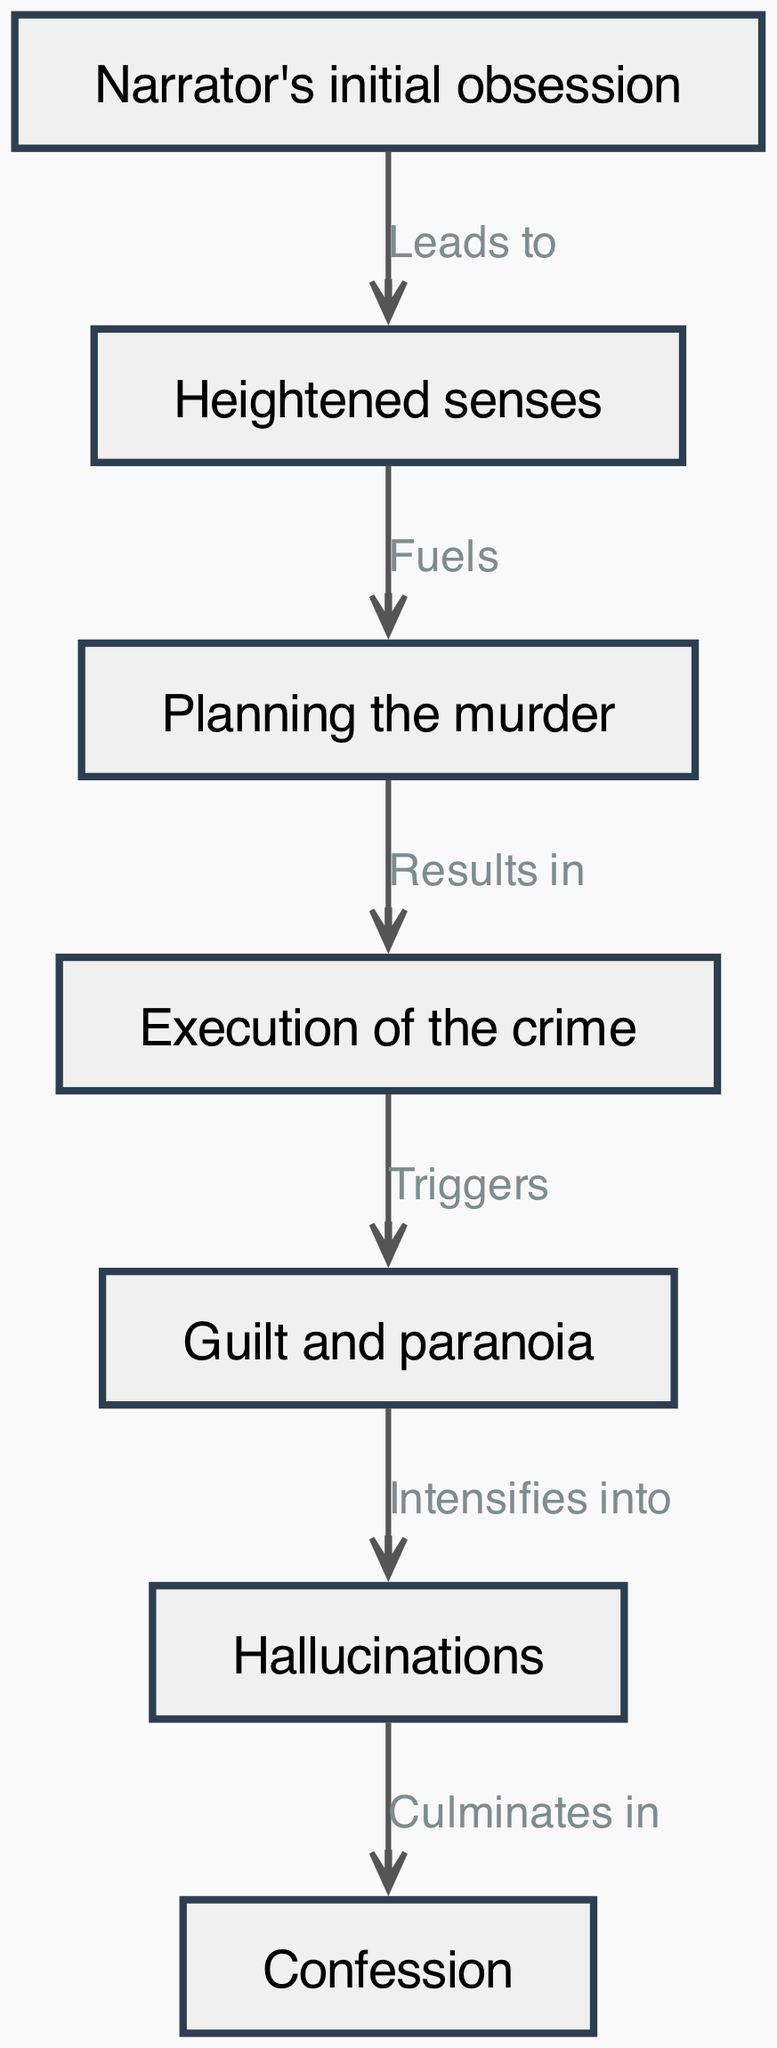What is the first node in the diagram? The first node listed in the diagram is "Narrator's initial obsession," which serves as the starting point for the progression of madness.
Answer: Narrator's initial obsession How many nodes are there in total? The diagram contains a total of seven nodes that represent different stages in the progression of madness in "The Tell-Tale Heart."
Answer: 7 What does "Heightened senses" lead to? According to the diagram, "Heightened senses" leads to "Planning the murder," indicating a direct progression from the enhancement of perception to the act of scheming.
Answer: Planning the murder What triggers the feeling of guilt and paranoia? The diagram states that the execution of the crime triggers "Guilt and paranoia," establishing a connection between carrying out the act and the subsequent emotional responses.
Answer: Guilt and paranoia What is the final stage in the progression of madness? The final stage as indicated in the diagram is "Confession," which culminates from the previous stages of madness experienced by the narrator.
Answer: Confession Which node connects "Planning the murder" and "Execution of the crime"? The connection between "Planning the murder" and "Execution of the crime" is established by the edge labeled "Results in," showing the outcome of the planning process.
Answer: Results in What intensifies into hallucinations? The diagram indicates that "Guilt and paranoia" intensifies into "Hallucinations," illustrating how the narrator's emotional turmoil escalates to a cognitive break.
Answer: Hallucinations How does the progression culminate? The progression culminates in "Confession," which is the final node that represents the narrator's acknowledgment of their actions, following the hallucinations.
Answer: Confession 